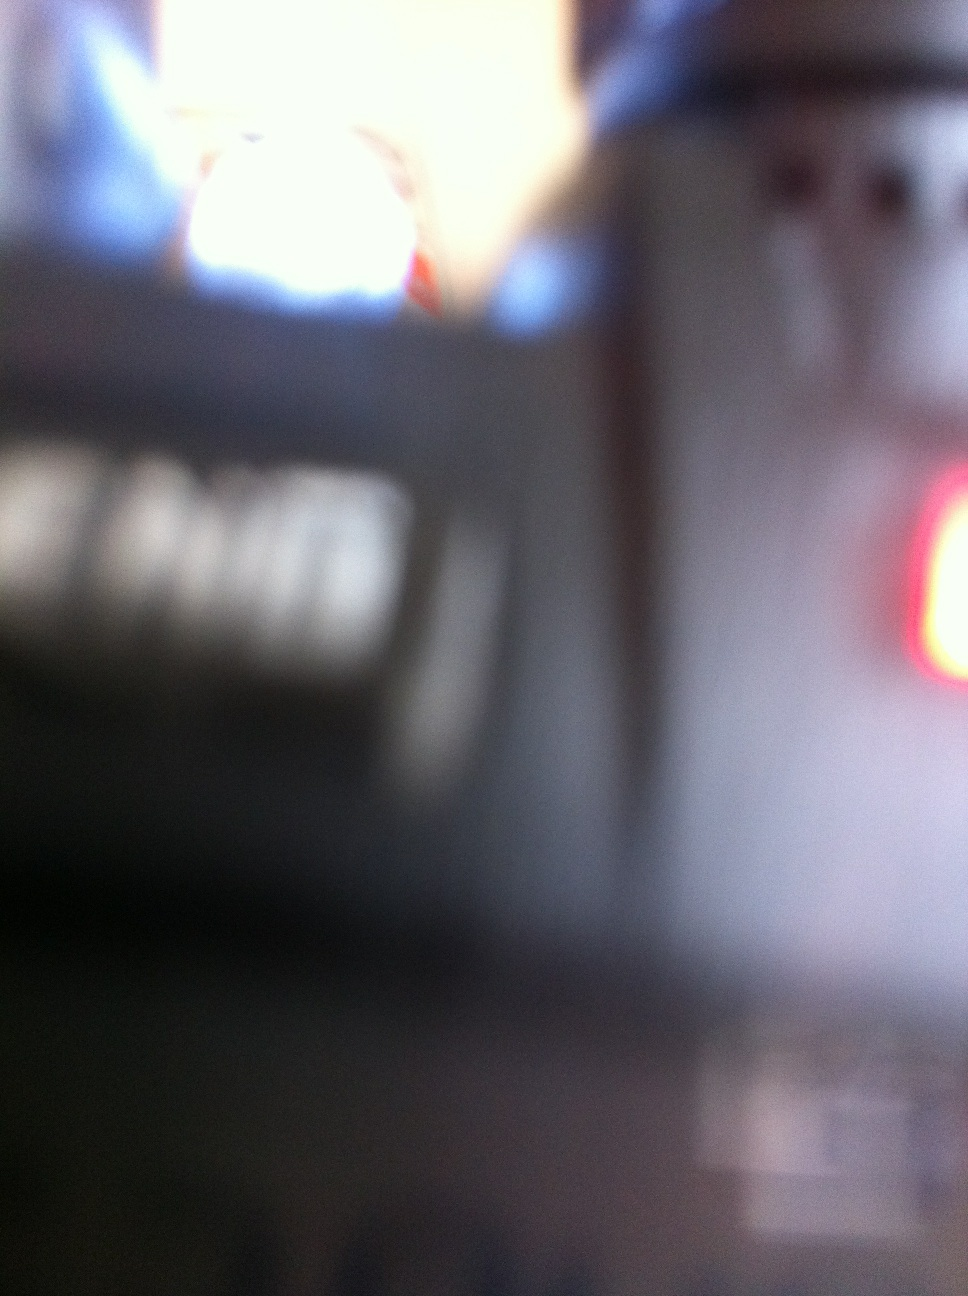Can you describe the object that is being held? The image appears to show a blurred view of a handheld radio. These devices are typically used for mobile communication, often featuring a speaker, a microphone, and a digital display for channels or settings. 